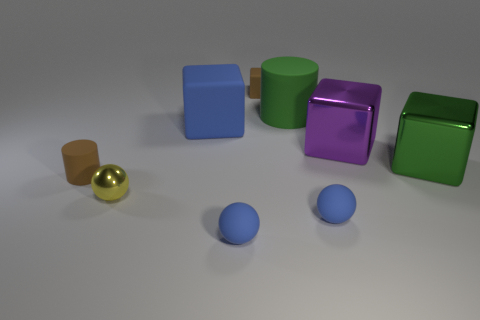How many other things are there of the same size as the brown block?
Give a very brief answer. 4. The cylinder that is the same color as the small matte block is what size?
Your response must be concise. Small. There is a tiny rubber object that is the same color as the tiny cylinder; what is its shape?
Offer a very short reply. Cube. There is a brown matte object behind the large block in front of the big purple metal thing; what size is it?
Give a very brief answer. Small. Is the shape of the brown rubber object behind the big green cube the same as the green thing in front of the big blue matte thing?
Give a very brief answer. Yes. Are there an equal number of cylinders right of the tiny yellow shiny ball and tiny purple shiny cubes?
Ensure brevity in your answer.  No. There is a tiny thing that is the same shape as the big blue thing; what color is it?
Your answer should be very brief. Brown. Is the material of the small brown thing in front of the green cube the same as the big blue cube?
Provide a short and direct response. Yes. How many large objects are yellow objects or brown cylinders?
Give a very brief answer. 0. What is the size of the brown block?
Your answer should be compact. Small. 